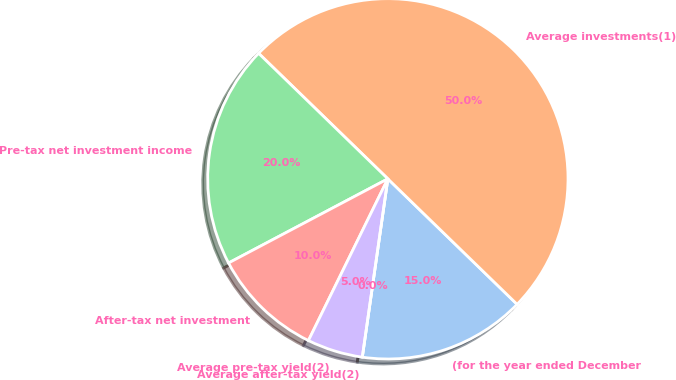Convert chart. <chart><loc_0><loc_0><loc_500><loc_500><pie_chart><fcel>(for the year ended December<fcel>Average investments(1)<fcel>Pre-tax net investment income<fcel>After-tax net investment<fcel>Average pre-tax yield(2)<fcel>Average after-tax yield(2)<nl><fcel>15.0%<fcel>50.0%<fcel>20.0%<fcel>10.0%<fcel>5.0%<fcel>0.0%<nl></chart> 